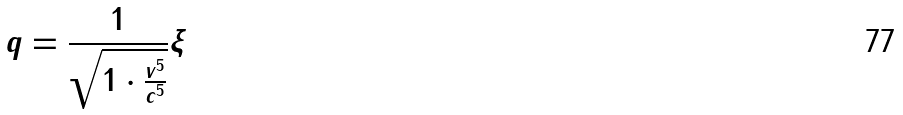Convert formula to latex. <formula><loc_0><loc_0><loc_500><loc_500>q = \frac { 1 } { \sqrt { 1 \cdot \frac { v ^ { 5 } } { c ^ { 5 } } } } \xi</formula> 